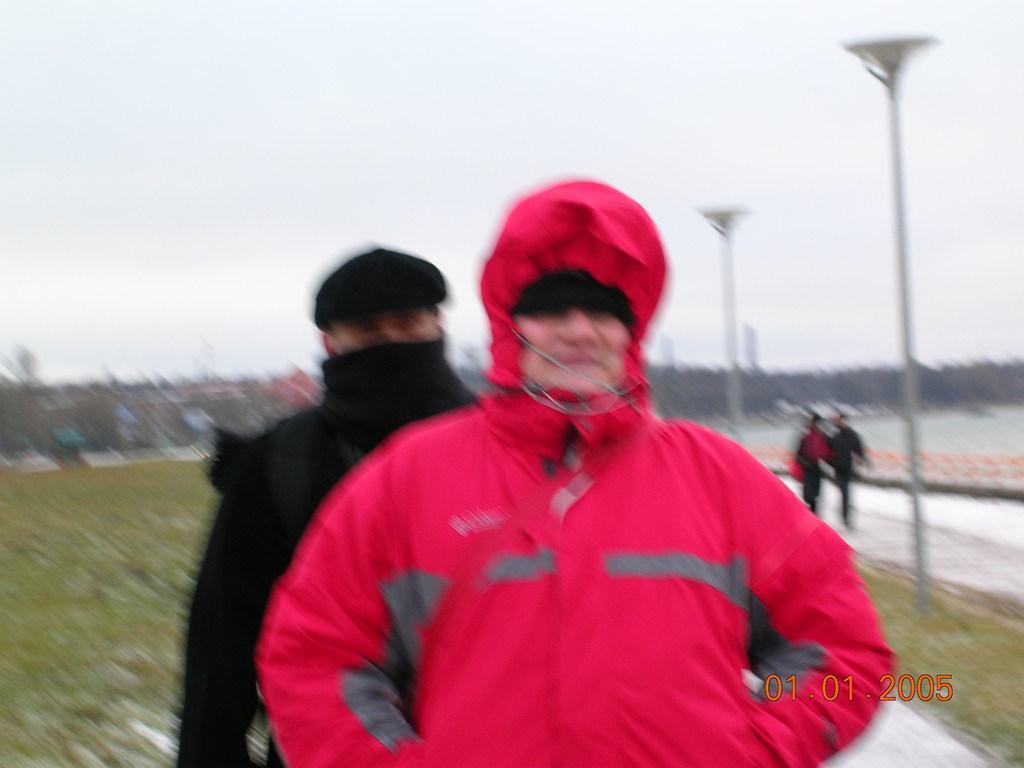Can you describe this image briefly? In this image in the foreground there are two persons standing, and they are wearing some costumes. And in the background there are trees, poles and two persons are walking. At the bottom there is grass and walkway and at the bottom of the image there is text, at the top there is sky. 